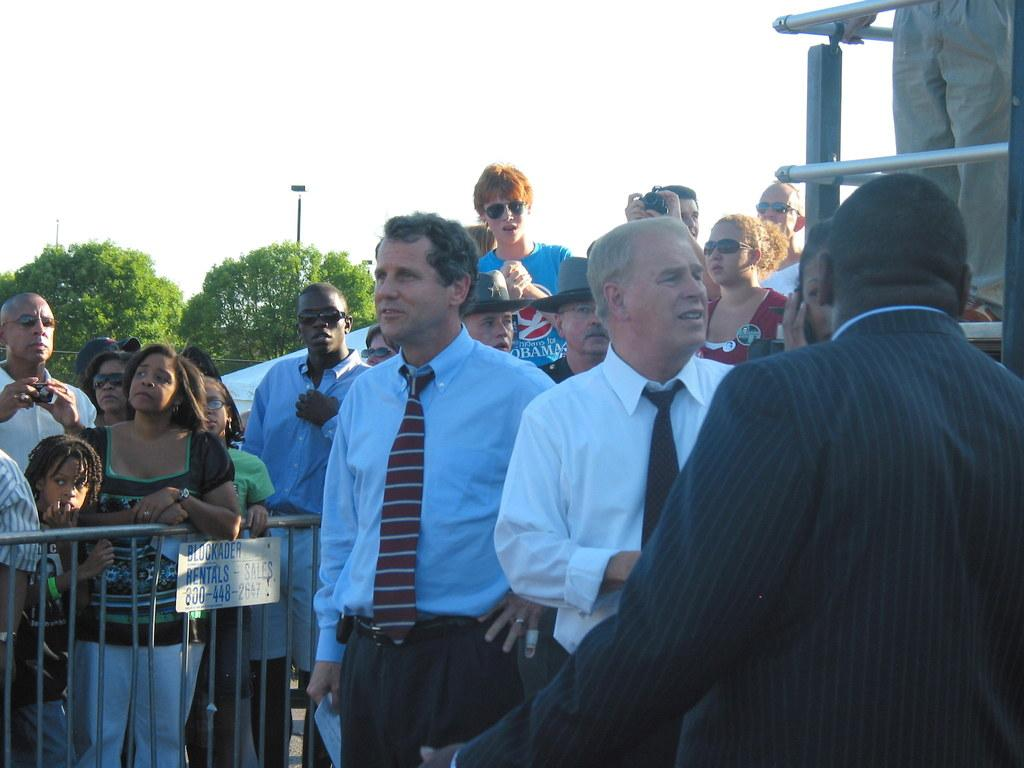What can be seen in the image? There are people standing in the image. What structures are present on the sides of the image? There is a fence on the left side and a railing on the right side of the image. What object can be seen in the image that is not related to the people or structures? There is a pole in the image. What can be seen in the distance in the image? There are trees visible in the background of the image. Can you describe the wave pattern of the people's clothing in the image? There is no wave pattern visible on the people's clothing in the image. 